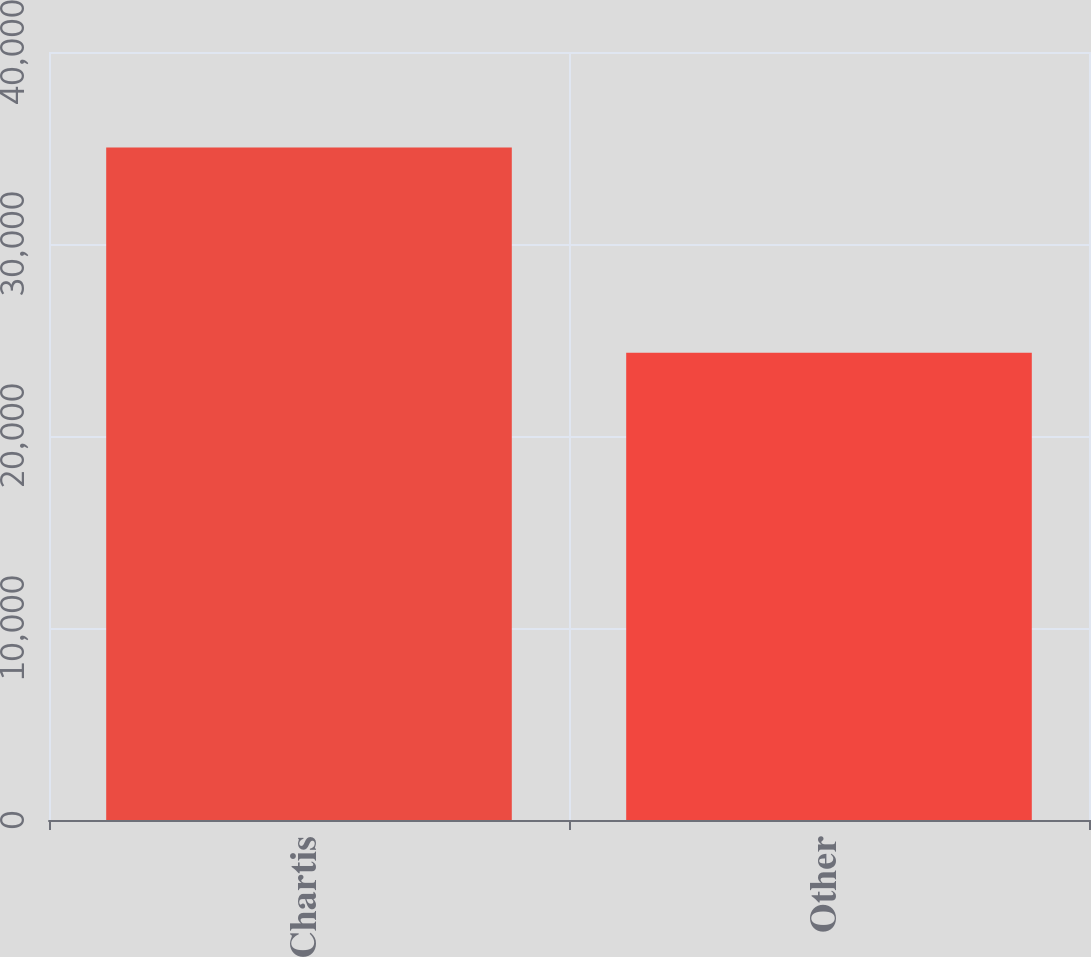Convert chart. <chart><loc_0><loc_0><loc_500><loc_500><bar_chart><fcel>Chartis<fcel>Other<nl><fcel>35023<fcel>24342<nl></chart> 